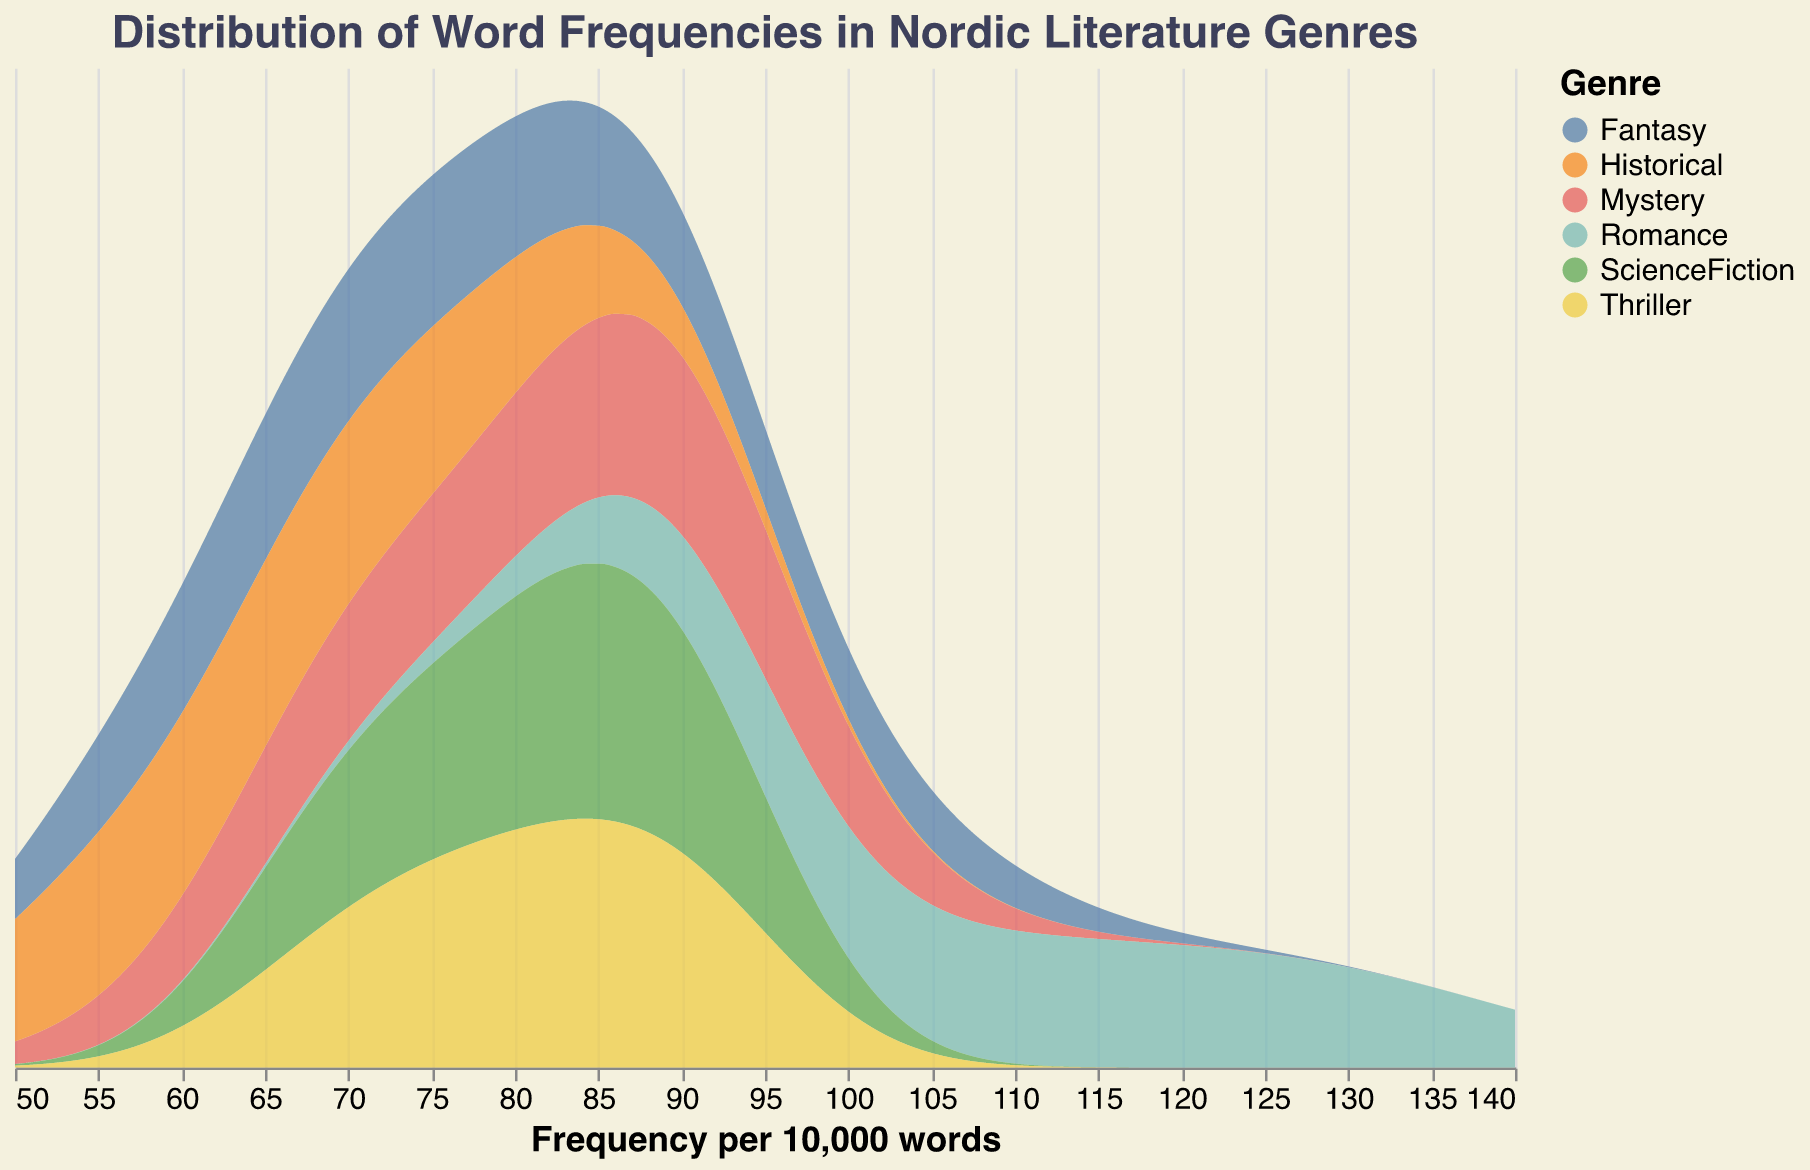What is the title of the figure? The title of the figure is located at the top center of the plot. It is prominently displayed and uses a larger font size compared to other textual elements. The title helps in understanding the overall purpose of the figure.
Answer: Distribution of Word Frequencies in Nordic Literature Genres How many genres are represented in the figure? The plot uses different colors to represent various genres. By looking at the legend on the right-hand side of the plot, we can count the number of distinct genres displayed.
Answer: 6 Which genre has the highest frequency for any word? To find the genre with the highest word frequency, look at the x-axis for the highest value of frequency, then check which colored area corresponds to this value.
Answer: Romance Which word in the Fantasy genre has the highest frequency? For this, look at the density plot's colored section for Fantasy, and then check which word within this genre has the highest peak in frequency.
Answer: magic Is there any genre that shows a consistent frequency distribution across its words? Examine the plot and identify if any genre's curve appears smooth and does not have sharp peaks or valleys across the x-axis, indicating a more consistent distribution.
Answer: No What's the frequency range covered by the Mystery genre? By looking at the start and end points along the x-axis for the portion of the plot colored for Mystery, we can determine the range it covers.
Answer: 65 to 94 Which genre has the lowest median word frequency? The median frequency can be estimated by looking at the middle point of the density area for each genre. Find the genre where this middle point is lowest on the x-axis.
Answer: Historical Compare the frequency distribution peaks of the ScienceFiction and Thriller genres. Identify the highest points (peaks) of the density plots for ScienceFiction and Thriller. Compare the x-axis values at these peaks to understand which genre’s words have higher peaks.
Answer: Thriller has a higher peak What's the average high peak frequency among all genres? Identify the highest peak for each genre on the x-axis, sum these peaks, and then divide by the number of genres to find the average. High peaks are the maximum points for density.
Answer: (94 + 102 + 132 + 92 + 81 + 91) / 6 = 99.67 